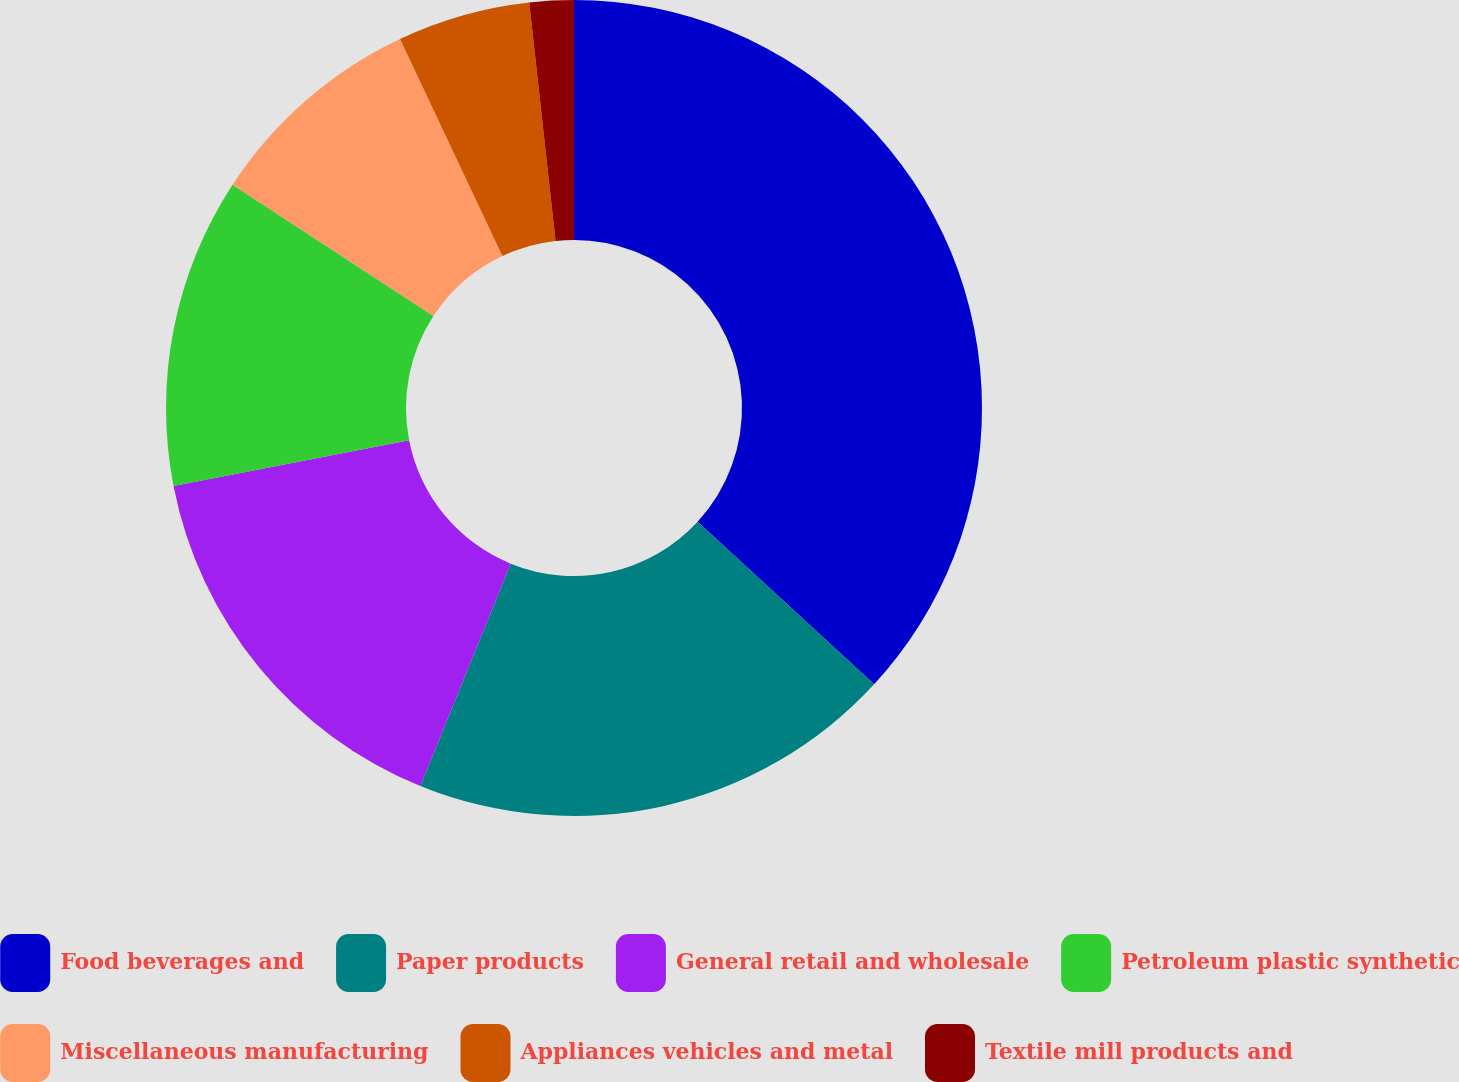Convert chart. <chart><loc_0><loc_0><loc_500><loc_500><pie_chart><fcel>Food beverages and<fcel>Paper products<fcel>General retail and wholesale<fcel>Petroleum plastic synthetic<fcel>Miscellaneous manufacturing<fcel>Appliances vehicles and metal<fcel>Textile mill products and<nl><fcel>36.84%<fcel>19.3%<fcel>15.79%<fcel>12.28%<fcel>8.77%<fcel>5.26%<fcel>1.75%<nl></chart> 